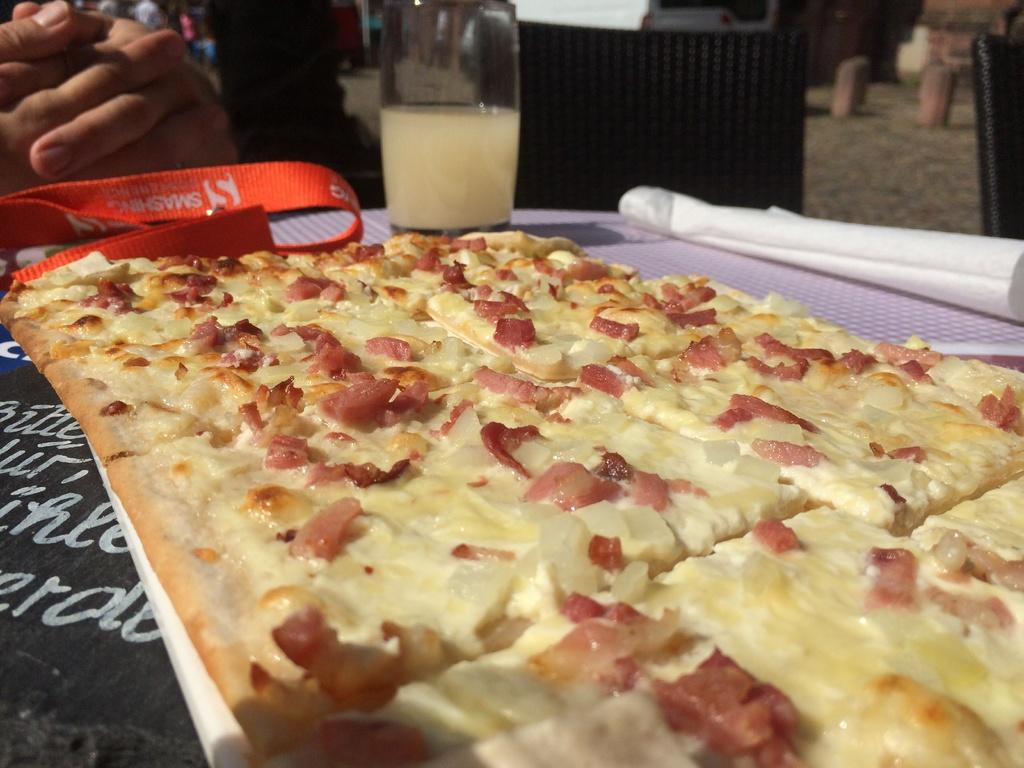What type of food item is in the image? There is a food item in the image, but the specific type is not mentioned in the facts. What else is present in the image besides the food item? There is paper and a tag in the image. Where are these items located? These items are on a platform. Can you describe the background of the image? In the background of the image, there are person's hands, chairs, and other objects visible. What type of gold jewelry is the daughter wearing in the image? There is no mention of a daughter or gold jewelry in the image or the provided facts. 